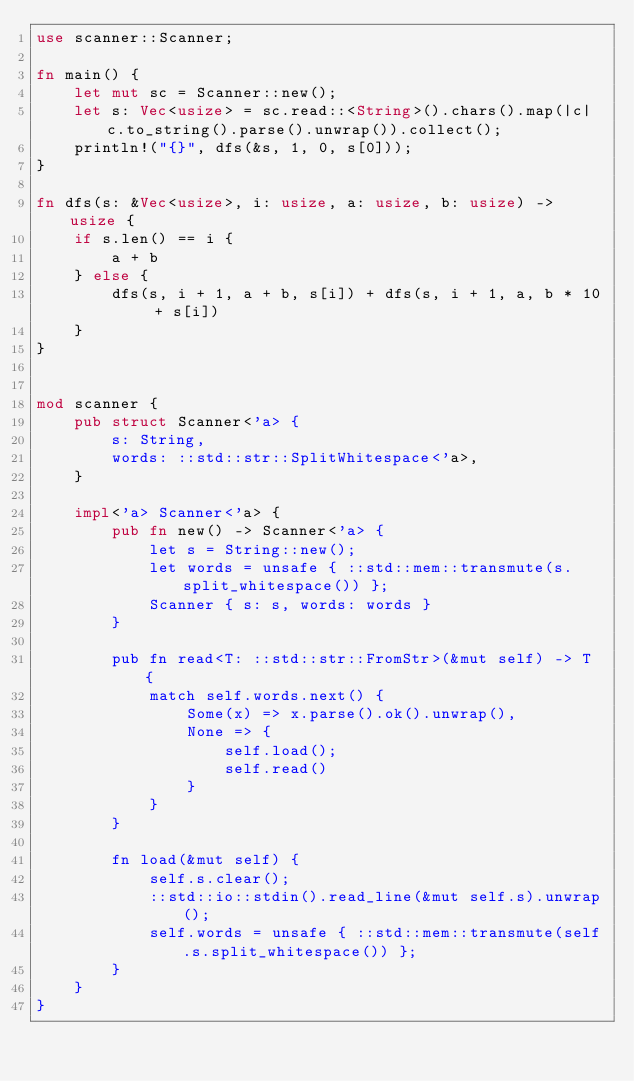Convert code to text. <code><loc_0><loc_0><loc_500><loc_500><_Rust_>use scanner::Scanner;

fn main() {
    let mut sc = Scanner::new();
    let s: Vec<usize> = sc.read::<String>().chars().map(|c| c.to_string().parse().unwrap()).collect();
    println!("{}", dfs(&s, 1, 0, s[0]));
}

fn dfs(s: &Vec<usize>, i: usize, a: usize, b: usize) -> usize {
    if s.len() == i {
        a + b
    } else {
        dfs(s, i + 1, a + b, s[i]) + dfs(s, i + 1, a, b * 10 + s[i])
    }
}


mod scanner {
    pub struct Scanner<'a> {
        s: String,
        words: ::std::str::SplitWhitespace<'a>,
    }

    impl<'a> Scanner<'a> {
        pub fn new() -> Scanner<'a> {
            let s = String::new();
            let words = unsafe { ::std::mem::transmute(s.split_whitespace()) };
            Scanner { s: s, words: words }
        }

        pub fn read<T: ::std::str::FromStr>(&mut self) -> T {
            match self.words.next() {
                Some(x) => x.parse().ok().unwrap(),
                None => {
                    self.load();
                    self.read()
                }
            }
        }

        fn load(&mut self) {
            self.s.clear();
            ::std::io::stdin().read_line(&mut self.s).unwrap();
            self.words = unsafe { ::std::mem::transmute(self.s.split_whitespace()) };
        }
    }
}
</code> 